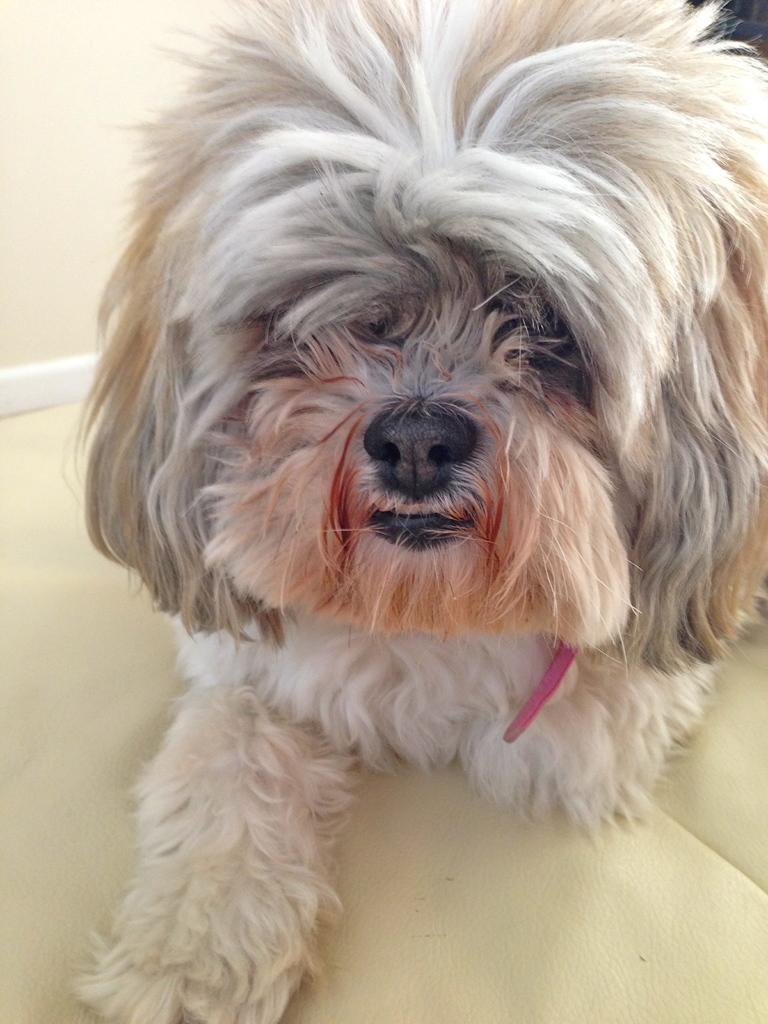What is the color of the object that the dog is on in the image? The object is cream-colored. What type of animal is on the cream-colored object? There is a white dog on the cream-colored object. What is the caption of the image? There is no caption present in the image. In which direction is the dog facing in the image? The direction the dog is facing cannot be determined from the image. 